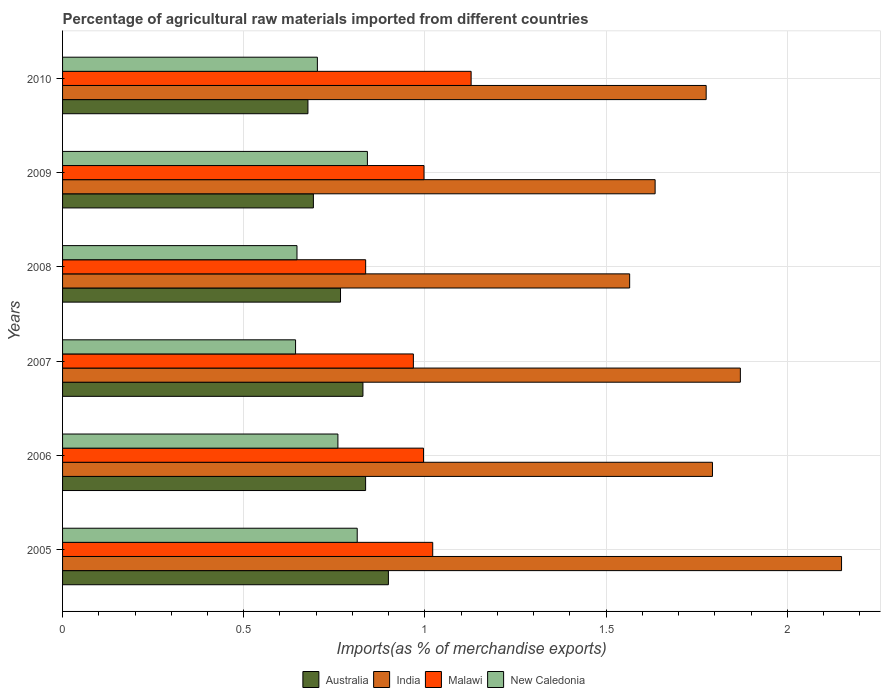How many groups of bars are there?
Make the answer very short. 6. Are the number of bars per tick equal to the number of legend labels?
Your answer should be compact. Yes. How many bars are there on the 4th tick from the bottom?
Offer a terse response. 4. What is the label of the 4th group of bars from the top?
Keep it short and to the point. 2007. In how many cases, is the number of bars for a given year not equal to the number of legend labels?
Give a very brief answer. 0. What is the percentage of imports to different countries in India in 2009?
Ensure brevity in your answer.  1.64. Across all years, what is the maximum percentage of imports to different countries in Malawi?
Provide a short and direct response. 1.13. Across all years, what is the minimum percentage of imports to different countries in Australia?
Give a very brief answer. 0.68. In which year was the percentage of imports to different countries in Malawi maximum?
Offer a very short reply. 2010. What is the total percentage of imports to different countries in India in the graph?
Keep it short and to the point. 10.79. What is the difference between the percentage of imports to different countries in India in 2006 and that in 2008?
Provide a short and direct response. 0.23. What is the difference between the percentage of imports to different countries in India in 2010 and the percentage of imports to different countries in Malawi in 2007?
Offer a terse response. 0.81. What is the average percentage of imports to different countries in India per year?
Your answer should be compact. 1.8. In the year 2008, what is the difference between the percentage of imports to different countries in New Caledonia and percentage of imports to different countries in Malawi?
Offer a very short reply. -0.19. What is the ratio of the percentage of imports to different countries in India in 2005 to that in 2007?
Keep it short and to the point. 1.15. Is the percentage of imports to different countries in India in 2006 less than that in 2009?
Your answer should be very brief. No. Is the difference between the percentage of imports to different countries in New Caledonia in 2006 and 2009 greater than the difference between the percentage of imports to different countries in Malawi in 2006 and 2009?
Your answer should be compact. No. What is the difference between the highest and the second highest percentage of imports to different countries in Malawi?
Your response must be concise. 0.11. What is the difference between the highest and the lowest percentage of imports to different countries in New Caledonia?
Give a very brief answer. 0.2. Is the sum of the percentage of imports to different countries in India in 2005 and 2006 greater than the maximum percentage of imports to different countries in New Caledonia across all years?
Offer a very short reply. Yes. Is it the case that in every year, the sum of the percentage of imports to different countries in Malawi and percentage of imports to different countries in Australia is greater than the sum of percentage of imports to different countries in New Caledonia and percentage of imports to different countries in India?
Ensure brevity in your answer.  No. What does the 1st bar from the top in 2005 represents?
Your answer should be very brief. New Caledonia. What does the 3rd bar from the bottom in 2009 represents?
Provide a succinct answer. Malawi. Is it the case that in every year, the sum of the percentage of imports to different countries in Australia and percentage of imports to different countries in India is greater than the percentage of imports to different countries in New Caledonia?
Offer a terse response. Yes. How many bars are there?
Offer a terse response. 24. How many years are there in the graph?
Ensure brevity in your answer.  6. Does the graph contain any zero values?
Offer a very short reply. No. Does the graph contain grids?
Make the answer very short. Yes. How are the legend labels stacked?
Give a very brief answer. Horizontal. What is the title of the graph?
Provide a succinct answer. Percentage of agricultural raw materials imported from different countries. Does "Equatorial Guinea" appear as one of the legend labels in the graph?
Your answer should be very brief. No. What is the label or title of the X-axis?
Ensure brevity in your answer.  Imports(as % of merchandise exports). What is the Imports(as % of merchandise exports) in Australia in 2005?
Provide a short and direct response. 0.9. What is the Imports(as % of merchandise exports) in India in 2005?
Offer a very short reply. 2.15. What is the Imports(as % of merchandise exports) in Malawi in 2005?
Offer a very short reply. 1.02. What is the Imports(as % of merchandise exports) in New Caledonia in 2005?
Offer a terse response. 0.81. What is the Imports(as % of merchandise exports) of Australia in 2006?
Provide a succinct answer. 0.84. What is the Imports(as % of merchandise exports) in India in 2006?
Offer a terse response. 1.79. What is the Imports(as % of merchandise exports) of Malawi in 2006?
Provide a short and direct response. 1. What is the Imports(as % of merchandise exports) of New Caledonia in 2006?
Give a very brief answer. 0.76. What is the Imports(as % of merchandise exports) in Australia in 2007?
Offer a terse response. 0.83. What is the Imports(as % of merchandise exports) of India in 2007?
Your answer should be very brief. 1.87. What is the Imports(as % of merchandise exports) in Malawi in 2007?
Offer a very short reply. 0.97. What is the Imports(as % of merchandise exports) of New Caledonia in 2007?
Provide a succinct answer. 0.64. What is the Imports(as % of merchandise exports) of Australia in 2008?
Your response must be concise. 0.77. What is the Imports(as % of merchandise exports) in India in 2008?
Give a very brief answer. 1.57. What is the Imports(as % of merchandise exports) of Malawi in 2008?
Provide a succinct answer. 0.84. What is the Imports(as % of merchandise exports) of New Caledonia in 2008?
Provide a succinct answer. 0.65. What is the Imports(as % of merchandise exports) of Australia in 2009?
Your answer should be very brief. 0.69. What is the Imports(as % of merchandise exports) in India in 2009?
Give a very brief answer. 1.64. What is the Imports(as % of merchandise exports) in Malawi in 2009?
Give a very brief answer. 1. What is the Imports(as % of merchandise exports) in New Caledonia in 2009?
Provide a short and direct response. 0.84. What is the Imports(as % of merchandise exports) of Australia in 2010?
Keep it short and to the point. 0.68. What is the Imports(as % of merchandise exports) in India in 2010?
Your response must be concise. 1.78. What is the Imports(as % of merchandise exports) of Malawi in 2010?
Offer a very short reply. 1.13. What is the Imports(as % of merchandise exports) of New Caledonia in 2010?
Your answer should be compact. 0.7. Across all years, what is the maximum Imports(as % of merchandise exports) in Australia?
Give a very brief answer. 0.9. Across all years, what is the maximum Imports(as % of merchandise exports) of India?
Provide a short and direct response. 2.15. Across all years, what is the maximum Imports(as % of merchandise exports) of Malawi?
Provide a succinct answer. 1.13. Across all years, what is the maximum Imports(as % of merchandise exports) of New Caledonia?
Give a very brief answer. 0.84. Across all years, what is the minimum Imports(as % of merchandise exports) in Australia?
Provide a short and direct response. 0.68. Across all years, what is the minimum Imports(as % of merchandise exports) of India?
Your answer should be very brief. 1.57. Across all years, what is the minimum Imports(as % of merchandise exports) of Malawi?
Your answer should be very brief. 0.84. Across all years, what is the minimum Imports(as % of merchandise exports) in New Caledonia?
Give a very brief answer. 0.64. What is the total Imports(as % of merchandise exports) of Australia in the graph?
Make the answer very short. 4.7. What is the total Imports(as % of merchandise exports) in India in the graph?
Provide a short and direct response. 10.79. What is the total Imports(as % of merchandise exports) of Malawi in the graph?
Your response must be concise. 5.95. What is the total Imports(as % of merchandise exports) of New Caledonia in the graph?
Give a very brief answer. 4.41. What is the difference between the Imports(as % of merchandise exports) in Australia in 2005 and that in 2006?
Keep it short and to the point. 0.06. What is the difference between the Imports(as % of merchandise exports) in India in 2005 and that in 2006?
Offer a terse response. 0.36. What is the difference between the Imports(as % of merchandise exports) of Malawi in 2005 and that in 2006?
Provide a short and direct response. 0.03. What is the difference between the Imports(as % of merchandise exports) in New Caledonia in 2005 and that in 2006?
Keep it short and to the point. 0.05. What is the difference between the Imports(as % of merchandise exports) in Australia in 2005 and that in 2007?
Your response must be concise. 0.07. What is the difference between the Imports(as % of merchandise exports) in India in 2005 and that in 2007?
Offer a terse response. 0.28. What is the difference between the Imports(as % of merchandise exports) of Malawi in 2005 and that in 2007?
Offer a very short reply. 0.05. What is the difference between the Imports(as % of merchandise exports) of New Caledonia in 2005 and that in 2007?
Ensure brevity in your answer.  0.17. What is the difference between the Imports(as % of merchandise exports) of Australia in 2005 and that in 2008?
Keep it short and to the point. 0.13. What is the difference between the Imports(as % of merchandise exports) in India in 2005 and that in 2008?
Ensure brevity in your answer.  0.58. What is the difference between the Imports(as % of merchandise exports) of Malawi in 2005 and that in 2008?
Provide a short and direct response. 0.19. What is the difference between the Imports(as % of merchandise exports) in New Caledonia in 2005 and that in 2008?
Provide a short and direct response. 0.17. What is the difference between the Imports(as % of merchandise exports) of Australia in 2005 and that in 2009?
Provide a succinct answer. 0.21. What is the difference between the Imports(as % of merchandise exports) of India in 2005 and that in 2009?
Provide a short and direct response. 0.51. What is the difference between the Imports(as % of merchandise exports) of Malawi in 2005 and that in 2009?
Offer a very short reply. 0.02. What is the difference between the Imports(as % of merchandise exports) in New Caledonia in 2005 and that in 2009?
Offer a terse response. -0.03. What is the difference between the Imports(as % of merchandise exports) in Australia in 2005 and that in 2010?
Provide a short and direct response. 0.22. What is the difference between the Imports(as % of merchandise exports) of India in 2005 and that in 2010?
Provide a succinct answer. 0.37. What is the difference between the Imports(as % of merchandise exports) of Malawi in 2005 and that in 2010?
Your answer should be very brief. -0.11. What is the difference between the Imports(as % of merchandise exports) in New Caledonia in 2005 and that in 2010?
Your answer should be compact. 0.11. What is the difference between the Imports(as % of merchandise exports) in Australia in 2006 and that in 2007?
Offer a very short reply. 0.01. What is the difference between the Imports(as % of merchandise exports) in India in 2006 and that in 2007?
Your response must be concise. -0.08. What is the difference between the Imports(as % of merchandise exports) in Malawi in 2006 and that in 2007?
Ensure brevity in your answer.  0.03. What is the difference between the Imports(as % of merchandise exports) of New Caledonia in 2006 and that in 2007?
Provide a short and direct response. 0.12. What is the difference between the Imports(as % of merchandise exports) of Australia in 2006 and that in 2008?
Your response must be concise. 0.07. What is the difference between the Imports(as % of merchandise exports) of India in 2006 and that in 2008?
Make the answer very short. 0.23. What is the difference between the Imports(as % of merchandise exports) in Malawi in 2006 and that in 2008?
Offer a terse response. 0.16. What is the difference between the Imports(as % of merchandise exports) of New Caledonia in 2006 and that in 2008?
Offer a very short reply. 0.11. What is the difference between the Imports(as % of merchandise exports) in Australia in 2006 and that in 2009?
Offer a very short reply. 0.14. What is the difference between the Imports(as % of merchandise exports) in India in 2006 and that in 2009?
Offer a terse response. 0.16. What is the difference between the Imports(as % of merchandise exports) in Malawi in 2006 and that in 2009?
Provide a succinct answer. -0. What is the difference between the Imports(as % of merchandise exports) of New Caledonia in 2006 and that in 2009?
Offer a very short reply. -0.08. What is the difference between the Imports(as % of merchandise exports) of Australia in 2006 and that in 2010?
Your response must be concise. 0.16. What is the difference between the Imports(as % of merchandise exports) of India in 2006 and that in 2010?
Offer a very short reply. 0.02. What is the difference between the Imports(as % of merchandise exports) of Malawi in 2006 and that in 2010?
Your answer should be very brief. -0.13. What is the difference between the Imports(as % of merchandise exports) of New Caledonia in 2006 and that in 2010?
Your answer should be very brief. 0.06. What is the difference between the Imports(as % of merchandise exports) in Australia in 2007 and that in 2008?
Ensure brevity in your answer.  0.06. What is the difference between the Imports(as % of merchandise exports) in India in 2007 and that in 2008?
Your response must be concise. 0.31. What is the difference between the Imports(as % of merchandise exports) of Malawi in 2007 and that in 2008?
Offer a very short reply. 0.13. What is the difference between the Imports(as % of merchandise exports) in New Caledonia in 2007 and that in 2008?
Ensure brevity in your answer.  -0. What is the difference between the Imports(as % of merchandise exports) in Australia in 2007 and that in 2009?
Your answer should be very brief. 0.14. What is the difference between the Imports(as % of merchandise exports) of India in 2007 and that in 2009?
Offer a very short reply. 0.24. What is the difference between the Imports(as % of merchandise exports) in Malawi in 2007 and that in 2009?
Offer a very short reply. -0.03. What is the difference between the Imports(as % of merchandise exports) of New Caledonia in 2007 and that in 2009?
Provide a succinct answer. -0.2. What is the difference between the Imports(as % of merchandise exports) in Australia in 2007 and that in 2010?
Your answer should be very brief. 0.15. What is the difference between the Imports(as % of merchandise exports) of India in 2007 and that in 2010?
Provide a short and direct response. 0.09. What is the difference between the Imports(as % of merchandise exports) in Malawi in 2007 and that in 2010?
Your response must be concise. -0.16. What is the difference between the Imports(as % of merchandise exports) of New Caledonia in 2007 and that in 2010?
Make the answer very short. -0.06. What is the difference between the Imports(as % of merchandise exports) in Australia in 2008 and that in 2009?
Keep it short and to the point. 0.07. What is the difference between the Imports(as % of merchandise exports) in India in 2008 and that in 2009?
Offer a terse response. -0.07. What is the difference between the Imports(as % of merchandise exports) in Malawi in 2008 and that in 2009?
Your response must be concise. -0.16. What is the difference between the Imports(as % of merchandise exports) in New Caledonia in 2008 and that in 2009?
Offer a very short reply. -0.19. What is the difference between the Imports(as % of merchandise exports) in Australia in 2008 and that in 2010?
Give a very brief answer. 0.09. What is the difference between the Imports(as % of merchandise exports) in India in 2008 and that in 2010?
Provide a short and direct response. -0.21. What is the difference between the Imports(as % of merchandise exports) in Malawi in 2008 and that in 2010?
Offer a terse response. -0.29. What is the difference between the Imports(as % of merchandise exports) in New Caledonia in 2008 and that in 2010?
Your response must be concise. -0.06. What is the difference between the Imports(as % of merchandise exports) of Australia in 2009 and that in 2010?
Offer a terse response. 0.02. What is the difference between the Imports(as % of merchandise exports) in India in 2009 and that in 2010?
Ensure brevity in your answer.  -0.14. What is the difference between the Imports(as % of merchandise exports) in Malawi in 2009 and that in 2010?
Offer a very short reply. -0.13. What is the difference between the Imports(as % of merchandise exports) in New Caledonia in 2009 and that in 2010?
Your response must be concise. 0.14. What is the difference between the Imports(as % of merchandise exports) in Australia in 2005 and the Imports(as % of merchandise exports) in India in 2006?
Your response must be concise. -0.89. What is the difference between the Imports(as % of merchandise exports) in Australia in 2005 and the Imports(as % of merchandise exports) in Malawi in 2006?
Offer a very short reply. -0.1. What is the difference between the Imports(as % of merchandise exports) in Australia in 2005 and the Imports(as % of merchandise exports) in New Caledonia in 2006?
Offer a very short reply. 0.14. What is the difference between the Imports(as % of merchandise exports) of India in 2005 and the Imports(as % of merchandise exports) of Malawi in 2006?
Make the answer very short. 1.15. What is the difference between the Imports(as % of merchandise exports) of India in 2005 and the Imports(as % of merchandise exports) of New Caledonia in 2006?
Make the answer very short. 1.39. What is the difference between the Imports(as % of merchandise exports) in Malawi in 2005 and the Imports(as % of merchandise exports) in New Caledonia in 2006?
Make the answer very short. 0.26. What is the difference between the Imports(as % of merchandise exports) of Australia in 2005 and the Imports(as % of merchandise exports) of India in 2007?
Your answer should be very brief. -0.97. What is the difference between the Imports(as % of merchandise exports) in Australia in 2005 and the Imports(as % of merchandise exports) in Malawi in 2007?
Keep it short and to the point. -0.07. What is the difference between the Imports(as % of merchandise exports) in Australia in 2005 and the Imports(as % of merchandise exports) in New Caledonia in 2007?
Make the answer very short. 0.26. What is the difference between the Imports(as % of merchandise exports) in India in 2005 and the Imports(as % of merchandise exports) in Malawi in 2007?
Your answer should be compact. 1.18. What is the difference between the Imports(as % of merchandise exports) in India in 2005 and the Imports(as % of merchandise exports) in New Caledonia in 2007?
Your answer should be compact. 1.51. What is the difference between the Imports(as % of merchandise exports) in Malawi in 2005 and the Imports(as % of merchandise exports) in New Caledonia in 2007?
Offer a very short reply. 0.38. What is the difference between the Imports(as % of merchandise exports) of Australia in 2005 and the Imports(as % of merchandise exports) of India in 2008?
Make the answer very short. -0.67. What is the difference between the Imports(as % of merchandise exports) in Australia in 2005 and the Imports(as % of merchandise exports) in Malawi in 2008?
Provide a short and direct response. 0.06. What is the difference between the Imports(as % of merchandise exports) in Australia in 2005 and the Imports(as % of merchandise exports) in New Caledonia in 2008?
Provide a succinct answer. 0.25. What is the difference between the Imports(as % of merchandise exports) in India in 2005 and the Imports(as % of merchandise exports) in Malawi in 2008?
Make the answer very short. 1.31. What is the difference between the Imports(as % of merchandise exports) of India in 2005 and the Imports(as % of merchandise exports) of New Caledonia in 2008?
Provide a succinct answer. 1.5. What is the difference between the Imports(as % of merchandise exports) of Malawi in 2005 and the Imports(as % of merchandise exports) of New Caledonia in 2008?
Provide a succinct answer. 0.37. What is the difference between the Imports(as % of merchandise exports) in Australia in 2005 and the Imports(as % of merchandise exports) in India in 2009?
Offer a terse response. -0.74. What is the difference between the Imports(as % of merchandise exports) in Australia in 2005 and the Imports(as % of merchandise exports) in Malawi in 2009?
Offer a very short reply. -0.1. What is the difference between the Imports(as % of merchandise exports) of Australia in 2005 and the Imports(as % of merchandise exports) of New Caledonia in 2009?
Provide a short and direct response. 0.06. What is the difference between the Imports(as % of merchandise exports) in India in 2005 and the Imports(as % of merchandise exports) in Malawi in 2009?
Offer a terse response. 1.15. What is the difference between the Imports(as % of merchandise exports) in India in 2005 and the Imports(as % of merchandise exports) in New Caledonia in 2009?
Provide a succinct answer. 1.31. What is the difference between the Imports(as % of merchandise exports) of Malawi in 2005 and the Imports(as % of merchandise exports) of New Caledonia in 2009?
Provide a succinct answer. 0.18. What is the difference between the Imports(as % of merchandise exports) of Australia in 2005 and the Imports(as % of merchandise exports) of India in 2010?
Provide a short and direct response. -0.88. What is the difference between the Imports(as % of merchandise exports) of Australia in 2005 and the Imports(as % of merchandise exports) of Malawi in 2010?
Give a very brief answer. -0.23. What is the difference between the Imports(as % of merchandise exports) of Australia in 2005 and the Imports(as % of merchandise exports) of New Caledonia in 2010?
Ensure brevity in your answer.  0.2. What is the difference between the Imports(as % of merchandise exports) of India in 2005 and the Imports(as % of merchandise exports) of Malawi in 2010?
Ensure brevity in your answer.  1.02. What is the difference between the Imports(as % of merchandise exports) of India in 2005 and the Imports(as % of merchandise exports) of New Caledonia in 2010?
Offer a terse response. 1.45. What is the difference between the Imports(as % of merchandise exports) in Malawi in 2005 and the Imports(as % of merchandise exports) in New Caledonia in 2010?
Give a very brief answer. 0.32. What is the difference between the Imports(as % of merchandise exports) of Australia in 2006 and the Imports(as % of merchandise exports) of India in 2007?
Your answer should be very brief. -1.03. What is the difference between the Imports(as % of merchandise exports) in Australia in 2006 and the Imports(as % of merchandise exports) in Malawi in 2007?
Ensure brevity in your answer.  -0.13. What is the difference between the Imports(as % of merchandise exports) in Australia in 2006 and the Imports(as % of merchandise exports) in New Caledonia in 2007?
Your answer should be compact. 0.19. What is the difference between the Imports(as % of merchandise exports) of India in 2006 and the Imports(as % of merchandise exports) of Malawi in 2007?
Your answer should be very brief. 0.83. What is the difference between the Imports(as % of merchandise exports) in India in 2006 and the Imports(as % of merchandise exports) in New Caledonia in 2007?
Offer a very short reply. 1.15. What is the difference between the Imports(as % of merchandise exports) in Malawi in 2006 and the Imports(as % of merchandise exports) in New Caledonia in 2007?
Provide a succinct answer. 0.35. What is the difference between the Imports(as % of merchandise exports) in Australia in 2006 and the Imports(as % of merchandise exports) in India in 2008?
Ensure brevity in your answer.  -0.73. What is the difference between the Imports(as % of merchandise exports) in Australia in 2006 and the Imports(as % of merchandise exports) in Malawi in 2008?
Provide a short and direct response. -0. What is the difference between the Imports(as % of merchandise exports) of Australia in 2006 and the Imports(as % of merchandise exports) of New Caledonia in 2008?
Keep it short and to the point. 0.19. What is the difference between the Imports(as % of merchandise exports) in India in 2006 and the Imports(as % of merchandise exports) in Malawi in 2008?
Ensure brevity in your answer.  0.96. What is the difference between the Imports(as % of merchandise exports) in India in 2006 and the Imports(as % of merchandise exports) in New Caledonia in 2008?
Provide a succinct answer. 1.15. What is the difference between the Imports(as % of merchandise exports) in Malawi in 2006 and the Imports(as % of merchandise exports) in New Caledonia in 2008?
Keep it short and to the point. 0.35. What is the difference between the Imports(as % of merchandise exports) in Australia in 2006 and the Imports(as % of merchandise exports) in India in 2009?
Provide a succinct answer. -0.8. What is the difference between the Imports(as % of merchandise exports) of Australia in 2006 and the Imports(as % of merchandise exports) of Malawi in 2009?
Offer a terse response. -0.16. What is the difference between the Imports(as % of merchandise exports) of Australia in 2006 and the Imports(as % of merchandise exports) of New Caledonia in 2009?
Provide a succinct answer. -0.01. What is the difference between the Imports(as % of merchandise exports) in India in 2006 and the Imports(as % of merchandise exports) in Malawi in 2009?
Provide a succinct answer. 0.8. What is the difference between the Imports(as % of merchandise exports) of India in 2006 and the Imports(as % of merchandise exports) of New Caledonia in 2009?
Keep it short and to the point. 0.95. What is the difference between the Imports(as % of merchandise exports) of Malawi in 2006 and the Imports(as % of merchandise exports) of New Caledonia in 2009?
Make the answer very short. 0.15. What is the difference between the Imports(as % of merchandise exports) in Australia in 2006 and the Imports(as % of merchandise exports) in India in 2010?
Make the answer very short. -0.94. What is the difference between the Imports(as % of merchandise exports) in Australia in 2006 and the Imports(as % of merchandise exports) in Malawi in 2010?
Your response must be concise. -0.29. What is the difference between the Imports(as % of merchandise exports) in Australia in 2006 and the Imports(as % of merchandise exports) in New Caledonia in 2010?
Your answer should be very brief. 0.13. What is the difference between the Imports(as % of merchandise exports) in India in 2006 and the Imports(as % of merchandise exports) in Malawi in 2010?
Offer a terse response. 0.67. What is the difference between the Imports(as % of merchandise exports) of India in 2006 and the Imports(as % of merchandise exports) of New Caledonia in 2010?
Keep it short and to the point. 1.09. What is the difference between the Imports(as % of merchandise exports) in Malawi in 2006 and the Imports(as % of merchandise exports) in New Caledonia in 2010?
Ensure brevity in your answer.  0.29. What is the difference between the Imports(as % of merchandise exports) of Australia in 2007 and the Imports(as % of merchandise exports) of India in 2008?
Give a very brief answer. -0.74. What is the difference between the Imports(as % of merchandise exports) in Australia in 2007 and the Imports(as % of merchandise exports) in Malawi in 2008?
Provide a short and direct response. -0.01. What is the difference between the Imports(as % of merchandise exports) of Australia in 2007 and the Imports(as % of merchandise exports) of New Caledonia in 2008?
Your response must be concise. 0.18. What is the difference between the Imports(as % of merchandise exports) in India in 2007 and the Imports(as % of merchandise exports) in Malawi in 2008?
Make the answer very short. 1.03. What is the difference between the Imports(as % of merchandise exports) of India in 2007 and the Imports(as % of merchandise exports) of New Caledonia in 2008?
Give a very brief answer. 1.22. What is the difference between the Imports(as % of merchandise exports) in Malawi in 2007 and the Imports(as % of merchandise exports) in New Caledonia in 2008?
Offer a terse response. 0.32. What is the difference between the Imports(as % of merchandise exports) of Australia in 2007 and the Imports(as % of merchandise exports) of India in 2009?
Make the answer very short. -0.81. What is the difference between the Imports(as % of merchandise exports) in Australia in 2007 and the Imports(as % of merchandise exports) in Malawi in 2009?
Your answer should be very brief. -0.17. What is the difference between the Imports(as % of merchandise exports) of Australia in 2007 and the Imports(as % of merchandise exports) of New Caledonia in 2009?
Your answer should be compact. -0.01. What is the difference between the Imports(as % of merchandise exports) of India in 2007 and the Imports(as % of merchandise exports) of Malawi in 2009?
Make the answer very short. 0.87. What is the difference between the Imports(as % of merchandise exports) in India in 2007 and the Imports(as % of merchandise exports) in New Caledonia in 2009?
Give a very brief answer. 1.03. What is the difference between the Imports(as % of merchandise exports) of Malawi in 2007 and the Imports(as % of merchandise exports) of New Caledonia in 2009?
Your answer should be very brief. 0.13. What is the difference between the Imports(as % of merchandise exports) of Australia in 2007 and the Imports(as % of merchandise exports) of India in 2010?
Give a very brief answer. -0.95. What is the difference between the Imports(as % of merchandise exports) in Australia in 2007 and the Imports(as % of merchandise exports) in Malawi in 2010?
Your response must be concise. -0.3. What is the difference between the Imports(as % of merchandise exports) of Australia in 2007 and the Imports(as % of merchandise exports) of New Caledonia in 2010?
Keep it short and to the point. 0.13. What is the difference between the Imports(as % of merchandise exports) of India in 2007 and the Imports(as % of merchandise exports) of Malawi in 2010?
Give a very brief answer. 0.74. What is the difference between the Imports(as % of merchandise exports) in India in 2007 and the Imports(as % of merchandise exports) in New Caledonia in 2010?
Offer a terse response. 1.17. What is the difference between the Imports(as % of merchandise exports) in Malawi in 2007 and the Imports(as % of merchandise exports) in New Caledonia in 2010?
Keep it short and to the point. 0.26. What is the difference between the Imports(as % of merchandise exports) of Australia in 2008 and the Imports(as % of merchandise exports) of India in 2009?
Ensure brevity in your answer.  -0.87. What is the difference between the Imports(as % of merchandise exports) of Australia in 2008 and the Imports(as % of merchandise exports) of Malawi in 2009?
Ensure brevity in your answer.  -0.23. What is the difference between the Imports(as % of merchandise exports) of Australia in 2008 and the Imports(as % of merchandise exports) of New Caledonia in 2009?
Ensure brevity in your answer.  -0.07. What is the difference between the Imports(as % of merchandise exports) of India in 2008 and the Imports(as % of merchandise exports) of Malawi in 2009?
Ensure brevity in your answer.  0.57. What is the difference between the Imports(as % of merchandise exports) in India in 2008 and the Imports(as % of merchandise exports) in New Caledonia in 2009?
Your response must be concise. 0.72. What is the difference between the Imports(as % of merchandise exports) of Malawi in 2008 and the Imports(as % of merchandise exports) of New Caledonia in 2009?
Offer a terse response. -0. What is the difference between the Imports(as % of merchandise exports) in Australia in 2008 and the Imports(as % of merchandise exports) in India in 2010?
Ensure brevity in your answer.  -1.01. What is the difference between the Imports(as % of merchandise exports) of Australia in 2008 and the Imports(as % of merchandise exports) of Malawi in 2010?
Ensure brevity in your answer.  -0.36. What is the difference between the Imports(as % of merchandise exports) of Australia in 2008 and the Imports(as % of merchandise exports) of New Caledonia in 2010?
Provide a short and direct response. 0.06. What is the difference between the Imports(as % of merchandise exports) of India in 2008 and the Imports(as % of merchandise exports) of Malawi in 2010?
Ensure brevity in your answer.  0.44. What is the difference between the Imports(as % of merchandise exports) in India in 2008 and the Imports(as % of merchandise exports) in New Caledonia in 2010?
Your answer should be very brief. 0.86. What is the difference between the Imports(as % of merchandise exports) of Malawi in 2008 and the Imports(as % of merchandise exports) of New Caledonia in 2010?
Provide a short and direct response. 0.13. What is the difference between the Imports(as % of merchandise exports) in Australia in 2009 and the Imports(as % of merchandise exports) in India in 2010?
Provide a short and direct response. -1.08. What is the difference between the Imports(as % of merchandise exports) in Australia in 2009 and the Imports(as % of merchandise exports) in Malawi in 2010?
Your answer should be compact. -0.44. What is the difference between the Imports(as % of merchandise exports) of Australia in 2009 and the Imports(as % of merchandise exports) of New Caledonia in 2010?
Offer a terse response. -0.01. What is the difference between the Imports(as % of merchandise exports) of India in 2009 and the Imports(as % of merchandise exports) of Malawi in 2010?
Provide a succinct answer. 0.51. What is the difference between the Imports(as % of merchandise exports) of India in 2009 and the Imports(as % of merchandise exports) of New Caledonia in 2010?
Ensure brevity in your answer.  0.93. What is the difference between the Imports(as % of merchandise exports) in Malawi in 2009 and the Imports(as % of merchandise exports) in New Caledonia in 2010?
Give a very brief answer. 0.29. What is the average Imports(as % of merchandise exports) in Australia per year?
Provide a short and direct response. 0.78. What is the average Imports(as % of merchandise exports) in India per year?
Make the answer very short. 1.8. What is the average Imports(as % of merchandise exports) in New Caledonia per year?
Offer a very short reply. 0.73. In the year 2005, what is the difference between the Imports(as % of merchandise exports) in Australia and Imports(as % of merchandise exports) in India?
Ensure brevity in your answer.  -1.25. In the year 2005, what is the difference between the Imports(as % of merchandise exports) of Australia and Imports(as % of merchandise exports) of Malawi?
Provide a succinct answer. -0.12. In the year 2005, what is the difference between the Imports(as % of merchandise exports) in Australia and Imports(as % of merchandise exports) in New Caledonia?
Give a very brief answer. 0.09. In the year 2005, what is the difference between the Imports(as % of merchandise exports) of India and Imports(as % of merchandise exports) of Malawi?
Your response must be concise. 1.13. In the year 2005, what is the difference between the Imports(as % of merchandise exports) in India and Imports(as % of merchandise exports) in New Caledonia?
Your answer should be compact. 1.34. In the year 2005, what is the difference between the Imports(as % of merchandise exports) of Malawi and Imports(as % of merchandise exports) of New Caledonia?
Keep it short and to the point. 0.21. In the year 2006, what is the difference between the Imports(as % of merchandise exports) of Australia and Imports(as % of merchandise exports) of India?
Make the answer very short. -0.96. In the year 2006, what is the difference between the Imports(as % of merchandise exports) of Australia and Imports(as % of merchandise exports) of Malawi?
Ensure brevity in your answer.  -0.16. In the year 2006, what is the difference between the Imports(as % of merchandise exports) of Australia and Imports(as % of merchandise exports) of New Caledonia?
Provide a short and direct response. 0.08. In the year 2006, what is the difference between the Imports(as % of merchandise exports) of India and Imports(as % of merchandise exports) of Malawi?
Make the answer very short. 0.8. In the year 2006, what is the difference between the Imports(as % of merchandise exports) in India and Imports(as % of merchandise exports) in New Caledonia?
Your response must be concise. 1.03. In the year 2006, what is the difference between the Imports(as % of merchandise exports) in Malawi and Imports(as % of merchandise exports) in New Caledonia?
Your response must be concise. 0.24. In the year 2007, what is the difference between the Imports(as % of merchandise exports) of Australia and Imports(as % of merchandise exports) of India?
Make the answer very short. -1.04. In the year 2007, what is the difference between the Imports(as % of merchandise exports) in Australia and Imports(as % of merchandise exports) in Malawi?
Ensure brevity in your answer.  -0.14. In the year 2007, what is the difference between the Imports(as % of merchandise exports) of Australia and Imports(as % of merchandise exports) of New Caledonia?
Ensure brevity in your answer.  0.19. In the year 2007, what is the difference between the Imports(as % of merchandise exports) in India and Imports(as % of merchandise exports) in Malawi?
Make the answer very short. 0.9. In the year 2007, what is the difference between the Imports(as % of merchandise exports) in India and Imports(as % of merchandise exports) in New Caledonia?
Ensure brevity in your answer.  1.23. In the year 2007, what is the difference between the Imports(as % of merchandise exports) in Malawi and Imports(as % of merchandise exports) in New Caledonia?
Your answer should be compact. 0.33. In the year 2008, what is the difference between the Imports(as % of merchandise exports) of Australia and Imports(as % of merchandise exports) of India?
Make the answer very short. -0.8. In the year 2008, what is the difference between the Imports(as % of merchandise exports) of Australia and Imports(as % of merchandise exports) of Malawi?
Keep it short and to the point. -0.07. In the year 2008, what is the difference between the Imports(as % of merchandise exports) in Australia and Imports(as % of merchandise exports) in New Caledonia?
Your answer should be compact. 0.12. In the year 2008, what is the difference between the Imports(as % of merchandise exports) in India and Imports(as % of merchandise exports) in Malawi?
Your response must be concise. 0.73. In the year 2008, what is the difference between the Imports(as % of merchandise exports) of India and Imports(as % of merchandise exports) of New Caledonia?
Your response must be concise. 0.92. In the year 2008, what is the difference between the Imports(as % of merchandise exports) of Malawi and Imports(as % of merchandise exports) of New Caledonia?
Offer a very short reply. 0.19. In the year 2009, what is the difference between the Imports(as % of merchandise exports) in Australia and Imports(as % of merchandise exports) in India?
Offer a very short reply. -0.94. In the year 2009, what is the difference between the Imports(as % of merchandise exports) of Australia and Imports(as % of merchandise exports) of Malawi?
Your answer should be compact. -0.31. In the year 2009, what is the difference between the Imports(as % of merchandise exports) of Australia and Imports(as % of merchandise exports) of New Caledonia?
Your answer should be compact. -0.15. In the year 2009, what is the difference between the Imports(as % of merchandise exports) of India and Imports(as % of merchandise exports) of Malawi?
Give a very brief answer. 0.64. In the year 2009, what is the difference between the Imports(as % of merchandise exports) of India and Imports(as % of merchandise exports) of New Caledonia?
Offer a very short reply. 0.79. In the year 2009, what is the difference between the Imports(as % of merchandise exports) in Malawi and Imports(as % of merchandise exports) in New Caledonia?
Make the answer very short. 0.16. In the year 2010, what is the difference between the Imports(as % of merchandise exports) in Australia and Imports(as % of merchandise exports) in India?
Keep it short and to the point. -1.1. In the year 2010, what is the difference between the Imports(as % of merchandise exports) in Australia and Imports(as % of merchandise exports) in Malawi?
Offer a terse response. -0.45. In the year 2010, what is the difference between the Imports(as % of merchandise exports) of Australia and Imports(as % of merchandise exports) of New Caledonia?
Your answer should be compact. -0.03. In the year 2010, what is the difference between the Imports(as % of merchandise exports) of India and Imports(as % of merchandise exports) of Malawi?
Ensure brevity in your answer.  0.65. In the year 2010, what is the difference between the Imports(as % of merchandise exports) of India and Imports(as % of merchandise exports) of New Caledonia?
Offer a very short reply. 1.07. In the year 2010, what is the difference between the Imports(as % of merchandise exports) of Malawi and Imports(as % of merchandise exports) of New Caledonia?
Offer a very short reply. 0.42. What is the ratio of the Imports(as % of merchandise exports) in Australia in 2005 to that in 2006?
Keep it short and to the point. 1.08. What is the ratio of the Imports(as % of merchandise exports) in India in 2005 to that in 2006?
Keep it short and to the point. 1.2. What is the ratio of the Imports(as % of merchandise exports) in Malawi in 2005 to that in 2006?
Give a very brief answer. 1.03. What is the ratio of the Imports(as % of merchandise exports) in New Caledonia in 2005 to that in 2006?
Your answer should be compact. 1.07. What is the ratio of the Imports(as % of merchandise exports) in Australia in 2005 to that in 2007?
Ensure brevity in your answer.  1.08. What is the ratio of the Imports(as % of merchandise exports) of India in 2005 to that in 2007?
Keep it short and to the point. 1.15. What is the ratio of the Imports(as % of merchandise exports) of Malawi in 2005 to that in 2007?
Keep it short and to the point. 1.06. What is the ratio of the Imports(as % of merchandise exports) in New Caledonia in 2005 to that in 2007?
Your response must be concise. 1.26. What is the ratio of the Imports(as % of merchandise exports) in Australia in 2005 to that in 2008?
Make the answer very short. 1.17. What is the ratio of the Imports(as % of merchandise exports) in India in 2005 to that in 2008?
Your response must be concise. 1.37. What is the ratio of the Imports(as % of merchandise exports) of Malawi in 2005 to that in 2008?
Offer a terse response. 1.22. What is the ratio of the Imports(as % of merchandise exports) in New Caledonia in 2005 to that in 2008?
Offer a very short reply. 1.26. What is the ratio of the Imports(as % of merchandise exports) in Australia in 2005 to that in 2009?
Provide a succinct answer. 1.3. What is the ratio of the Imports(as % of merchandise exports) in India in 2005 to that in 2009?
Keep it short and to the point. 1.31. What is the ratio of the Imports(as % of merchandise exports) of Malawi in 2005 to that in 2009?
Your answer should be compact. 1.02. What is the ratio of the Imports(as % of merchandise exports) in New Caledonia in 2005 to that in 2009?
Offer a terse response. 0.97. What is the ratio of the Imports(as % of merchandise exports) of Australia in 2005 to that in 2010?
Your answer should be very brief. 1.33. What is the ratio of the Imports(as % of merchandise exports) of India in 2005 to that in 2010?
Give a very brief answer. 1.21. What is the ratio of the Imports(as % of merchandise exports) of Malawi in 2005 to that in 2010?
Make the answer very short. 0.91. What is the ratio of the Imports(as % of merchandise exports) in New Caledonia in 2005 to that in 2010?
Ensure brevity in your answer.  1.16. What is the ratio of the Imports(as % of merchandise exports) in Australia in 2006 to that in 2007?
Offer a very short reply. 1.01. What is the ratio of the Imports(as % of merchandise exports) of India in 2006 to that in 2007?
Offer a very short reply. 0.96. What is the ratio of the Imports(as % of merchandise exports) of Malawi in 2006 to that in 2007?
Give a very brief answer. 1.03. What is the ratio of the Imports(as % of merchandise exports) of New Caledonia in 2006 to that in 2007?
Your answer should be very brief. 1.18. What is the ratio of the Imports(as % of merchandise exports) of Australia in 2006 to that in 2008?
Make the answer very short. 1.09. What is the ratio of the Imports(as % of merchandise exports) in India in 2006 to that in 2008?
Offer a very short reply. 1.15. What is the ratio of the Imports(as % of merchandise exports) in Malawi in 2006 to that in 2008?
Your response must be concise. 1.19. What is the ratio of the Imports(as % of merchandise exports) of New Caledonia in 2006 to that in 2008?
Keep it short and to the point. 1.17. What is the ratio of the Imports(as % of merchandise exports) of Australia in 2006 to that in 2009?
Provide a short and direct response. 1.21. What is the ratio of the Imports(as % of merchandise exports) of India in 2006 to that in 2009?
Provide a short and direct response. 1.1. What is the ratio of the Imports(as % of merchandise exports) in Malawi in 2006 to that in 2009?
Offer a terse response. 1. What is the ratio of the Imports(as % of merchandise exports) in New Caledonia in 2006 to that in 2009?
Make the answer very short. 0.9. What is the ratio of the Imports(as % of merchandise exports) of Australia in 2006 to that in 2010?
Keep it short and to the point. 1.24. What is the ratio of the Imports(as % of merchandise exports) of India in 2006 to that in 2010?
Provide a succinct answer. 1.01. What is the ratio of the Imports(as % of merchandise exports) in Malawi in 2006 to that in 2010?
Keep it short and to the point. 0.88. What is the ratio of the Imports(as % of merchandise exports) of New Caledonia in 2006 to that in 2010?
Your answer should be compact. 1.08. What is the ratio of the Imports(as % of merchandise exports) of Australia in 2007 to that in 2008?
Your answer should be very brief. 1.08. What is the ratio of the Imports(as % of merchandise exports) of India in 2007 to that in 2008?
Make the answer very short. 1.2. What is the ratio of the Imports(as % of merchandise exports) of Malawi in 2007 to that in 2008?
Your response must be concise. 1.16. What is the ratio of the Imports(as % of merchandise exports) of Australia in 2007 to that in 2009?
Make the answer very short. 1.2. What is the ratio of the Imports(as % of merchandise exports) of India in 2007 to that in 2009?
Ensure brevity in your answer.  1.14. What is the ratio of the Imports(as % of merchandise exports) in Malawi in 2007 to that in 2009?
Make the answer very short. 0.97. What is the ratio of the Imports(as % of merchandise exports) in New Caledonia in 2007 to that in 2009?
Provide a short and direct response. 0.76. What is the ratio of the Imports(as % of merchandise exports) of Australia in 2007 to that in 2010?
Keep it short and to the point. 1.22. What is the ratio of the Imports(as % of merchandise exports) in India in 2007 to that in 2010?
Offer a terse response. 1.05. What is the ratio of the Imports(as % of merchandise exports) in Malawi in 2007 to that in 2010?
Keep it short and to the point. 0.86. What is the ratio of the Imports(as % of merchandise exports) of New Caledonia in 2007 to that in 2010?
Provide a short and direct response. 0.91. What is the ratio of the Imports(as % of merchandise exports) of Australia in 2008 to that in 2009?
Your response must be concise. 1.11. What is the ratio of the Imports(as % of merchandise exports) in Malawi in 2008 to that in 2009?
Give a very brief answer. 0.84. What is the ratio of the Imports(as % of merchandise exports) of New Caledonia in 2008 to that in 2009?
Give a very brief answer. 0.77. What is the ratio of the Imports(as % of merchandise exports) of Australia in 2008 to that in 2010?
Make the answer very short. 1.13. What is the ratio of the Imports(as % of merchandise exports) in India in 2008 to that in 2010?
Your answer should be compact. 0.88. What is the ratio of the Imports(as % of merchandise exports) in Malawi in 2008 to that in 2010?
Make the answer very short. 0.74. What is the ratio of the Imports(as % of merchandise exports) in New Caledonia in 2008 to that in 2010?
Provide a succinct answer. 0.92. What is the ratio of the Imports(as % of merchandise exports) in Australia in 2009 to that in 2010?
Ensure brevity in your answer.  1.02. What is the ratio of the Imports(as % of merchandise exports) in India in 2009 to that in 2010?
Give a very brief answer. 0.92. What is the ratio of the Imports(as % of merchandise exports) of Malawi in 2009 to that in 2010?
Make the answer very short. 0.88. What is the ratio of the Imports(as % of merchandise exports) of New Caledonia in 2009 to that in 2010?
Your response must be concise. 1.2. What is the difference between the highest and the second highest Imports(as % of merchandise exports) in Australia?
Your response must be concise. 0.06. What is the difference between the highest and the second highest Imports(as % of merchandise exports) in India?
Offer a terse response. 0.28. What is the difference between the highest and the second highest Imports(as % of merchandise exports) of Malawi?
Provide a succinct answer. 0.11. What is the difference between the highest and the second highest Imports(as % of merchandise exports) of New Caledonia?
Keep it short and to the point. 0.03. What is the difference between the highest and the lowest Imports(as % of merchandise exports) in Australia?
Your response must be concise. 0.22. What is the difference between the highest and the lowest Imports(as % of merchandise exports) in India?
Ensure brevity in your answer.  0.58. What is the difference between the highest and the lowest Imports(as % of merchandise exports) in Malawi?
Keep it short and to the point. 0.29. What is the difference between the highest and the lowest Imports(as % of merchandise exports) of New Caledonia?
Ensure brevity in your answer.  0.2. 